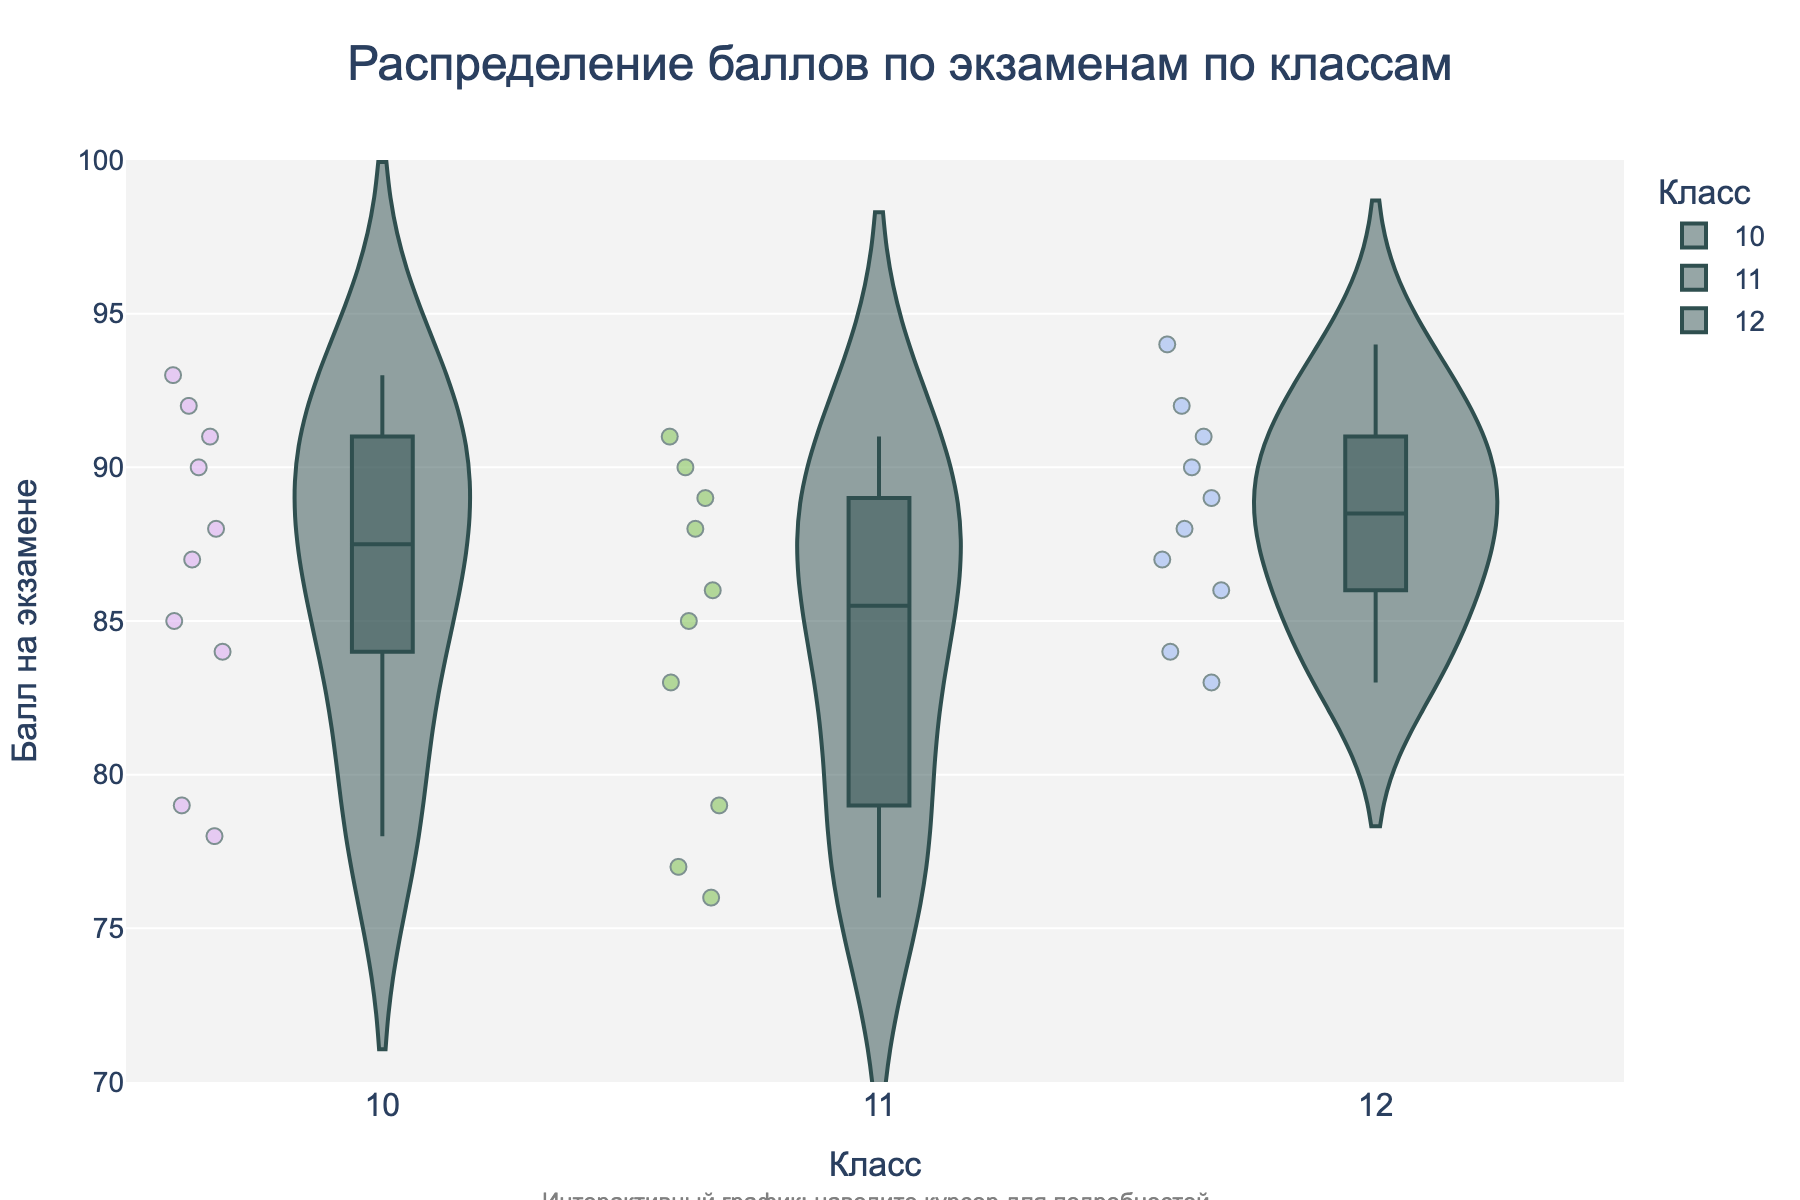What is the title of the figure? The title is displayed at the top center of the figure and reads "Распределение баллов по экзаменам по классам."
Answer: Распределение баллов по экзаменам по классам What is the range of scores displayed on the y-axis? The range of scores on the y-axis is from the minimum value at the bottom to the maximum value at the top. The axis labels indicate values from 70 to 100.
Answer: 70 to 100 Which grade level has the student with the highest exam score? By examining the top points within each violin, the highest score is observed at the top of the Grade 12 distribution.
Answer: Grade 12 How many students scored above 90 in Grade 10? By inspecting the jitter points within the Grade 10 violin plot, look for points above the 90-mark. There are three such points.
Answer: 3 What is the median exam score for Grade 11 students? The median score for each grade level is shown as a line inside the box plot within the violin. For Grade 11, the median line is around 85.
Answer: 85 Which grade level has the highest variance in exam scores? Variance can be inferred from the width of the distribution. The Grade 11 violin plot shows the widest spread, indicating the highest variance.
Answer: Grade 11 How does the distribution shape of exam scores in Grade 12 compare to that in Grade 10? The Grade 12 violin plot shows a more uniform and narrow distribution around the higher scores, while the Grade 10 plot has a wider and more varied distribution.
Answer: Grade 12 has a narrower, more uniform distribution compared to Grade 10 Is there overlap in the exam score range between the grades? Comparing the violin plots, all three grades show overlapping score ranges.
Answer: Yes What is the most common exam score range for Grade 12 students? The density of the violin plot for Grade 12 is highest around the 85 to 95 range, indicating the most common scores.
Answer: 85 to 95 Which grade level has the least number of students scoring below 80? Inspecting the jitter points below the 80-mark, Grade 12 has the least number of such points.
Answer: Grade 12 